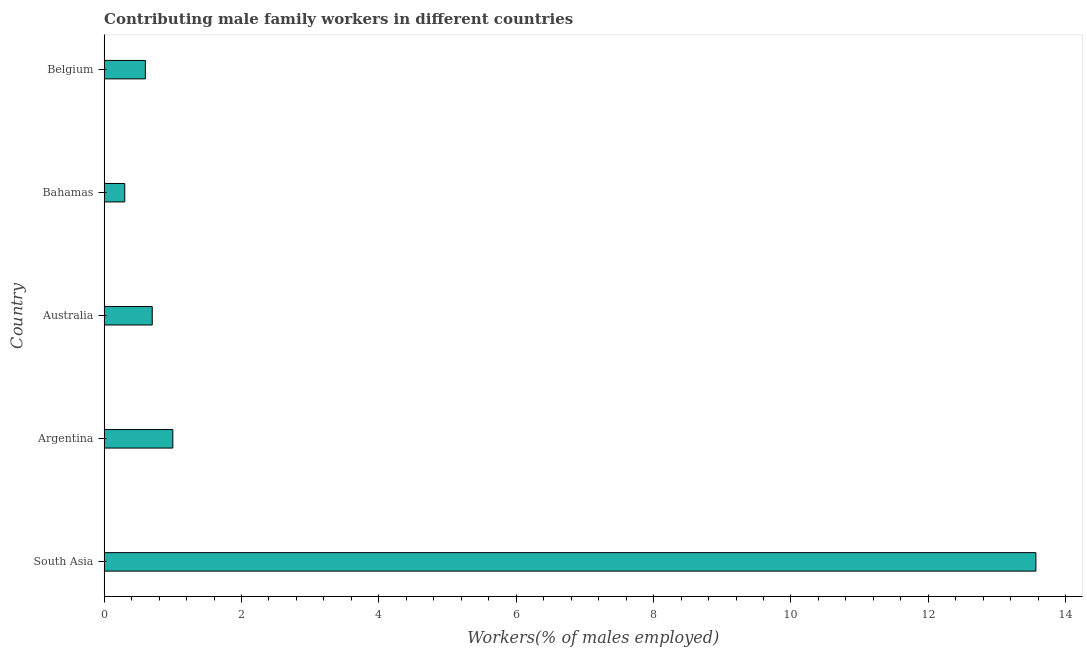Does the graph contain any zero values?
Your answer should be compact. No. Does the graph contain grids?
Ensure brevity in your answer.  No. What is the title of the graph?
Provide a short and direct response. Contributing male family workers in different countries. What is the label or title of the X-axis?
Offer a terse response. Workers(% of males employed). What is the label or title of the Y-axis?
Offer a very short reply. Country. Across all countries, what is the maximum contributing male family workers?
Provide a short and direct response. 13.57. Across all countries, what is the minimum contributing male family workers?
Your answer should be very brief. 0.3. In which country was the contributing male family workers maximum?
Your answer should be compact. South Asia. In which country was the contributing male family workers minimum?
Provide a short and direct response. Bahamas. What is the sum of the contributing male family workers?
Offer a terse response. 16.17. What is the difference between the contributing male family workers in Argentina and South Asia?
Give a very brief answer. -12.57. What is the average contributing male family workers per country?
Offer a terse response. 3.23. What is the median contributing male family workers?
Your answer should be compact. 0.7. What is the ratio of the contributing male family workers in Australia to that in Bahamas?
Provide a succinct answer. 2.33. Is the contributing male family workers in Australia less than that in South Asia?
Give a very brief answer. Yes. What is the difference between the highest and the second highest contributing male family workers?
Provide a short and direct response. 12.57. Is the sum of the contributing male family workers in Argentina and Belgium greater than the maximum contributing male family workers across all countries?
Your answer should be very brief. No. What is the difference between the highest and the lowest contributing male family workers?
Your response must be concise. 13.27. How many bars are there?
Make the answer very short. 5. Are all the bars in the graph horizontal?
Provide a short and direct response. Yes. How many countries are there in the graph?
Your answer should be very brief. 5. What is the difference between two consecutive major ticks on the X-axis?
Ensure brevity in your answer.  2. Are the values on the major ticks of X-axis written in scientific E-notation?
Keep it short and to the point. No. What is the Workers(% of males employed) in South Asia?
Your response must be concise. 13.57. What is the Workers(% of males employed) in Australia?
Give a very brief answer. 0.7. What is the Workers(% of males employed) in Bahamas?
Keep it short and to the point. 0.3. What is the Workers(% of males employed) of Belgium?
Your answer should be very brief. 0.6. What is the difference between the Workers(% of males employed) in South Asia and Argentina?
Your answer should be very brief. 12.57. What is the difference between the Workers(% of males employed) in South Asia and Australia?
Give a very brief answer. 12.87. What is the difference between the Workers(% of males employed) in South Asia and Bahamas?
Provide a succinct answer. 13.27. What is the difference between the Workers(% of males employed) in South Asia and Belgium?
Provide a short and direct response. 12.97. What is the difference between the Workers(% of males employed) in Argentina and Australia?
Offer a very short reply. 0.3. What is the difference between the Workers(% of males employed) in Australia and Bahamas?
Ensure brevity in your answer.  0.4. What is the difference between the Workers(% of males employed) in Australia and Belgium?
Your answer should be compact. 0.1. What is the difference between the Workers(% of males employed) in Bahamas and Belgium?
Keep it short and to the point. -0.3. What is the ratio of the Workers(% of males employed) in South Asia to that in Argentina?
Offer a terse response. 13.57. What is the ratio of the Workers(% of males employed) in South Asia to that in Australia?
Give a very brief answer. 19.38. What is the ratio of the Workers(% of males employed) in South Asia to that in Bahamas?
Provide a short and direct response. 45.22. What is the ratio of the Workers(% of males employed) in South Asia to that in Belgium?
Ensure brevity in your answer.  22.61. What is the ratio of the Workers(% of males employed) in Argentina to that in Australia?
Your response must be concise. 1.43. What is the ratio of the Workers(% of males employed) in Argentina to that in Bahamas?
Offer a terse response. 3.33. What is the ratio of the Workers(% of males employed) in Argentina to that in Belgium?
Your answer should be compact. 1.67. What is the ratio of the Workers(% of males employed) in Australia to that in Bahamas?
Give a very brief answer. 2.33. What is the ratio of the Workers(% of males employed) in Australia to that in Belgium?
Give a very brief answer. 1.17. What is the ratio of the Workers(% of males employed) in Bahamas to that in Belgium?
Make the answer very short. 0.5. 